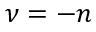Convert formula to latex. <formula><loc_0><loc_0><loc_500><loc_500>\nu = - n</formula> 